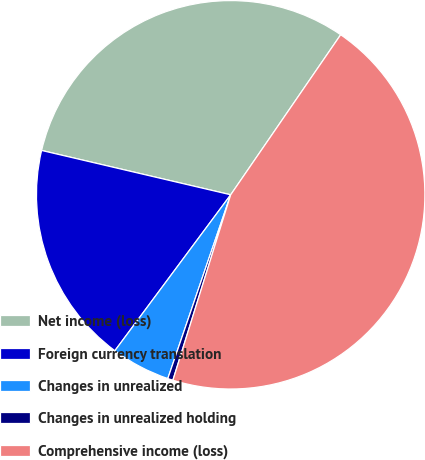Convert chart. <chart><loc_0><loc_0><loc_500><loc_500><pie_chart><fcel>Net income (loss)<fcel>Foreign currency translation<fcel>Changes in unrealized<fcel>Changes in unrealized holding<fcel>Comprehensive income (loss)<nl><fcel>30.92%<fcel>18.5%<fcel>4.92%<fcel>0.44%<fcel>45.23%<nl></chart> 